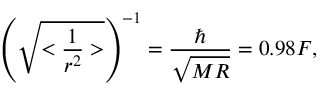Convert formula to latex. <formula><loc_0><loc_0><loc_500><loc_500>\left ( \sqrt { < \frac { 1 } { r ^ { 2 } } > } \right ) ^ { - 1 } = \frac { } { \sqrt { M R } } = 0 . 9 8 F ,</formula> 